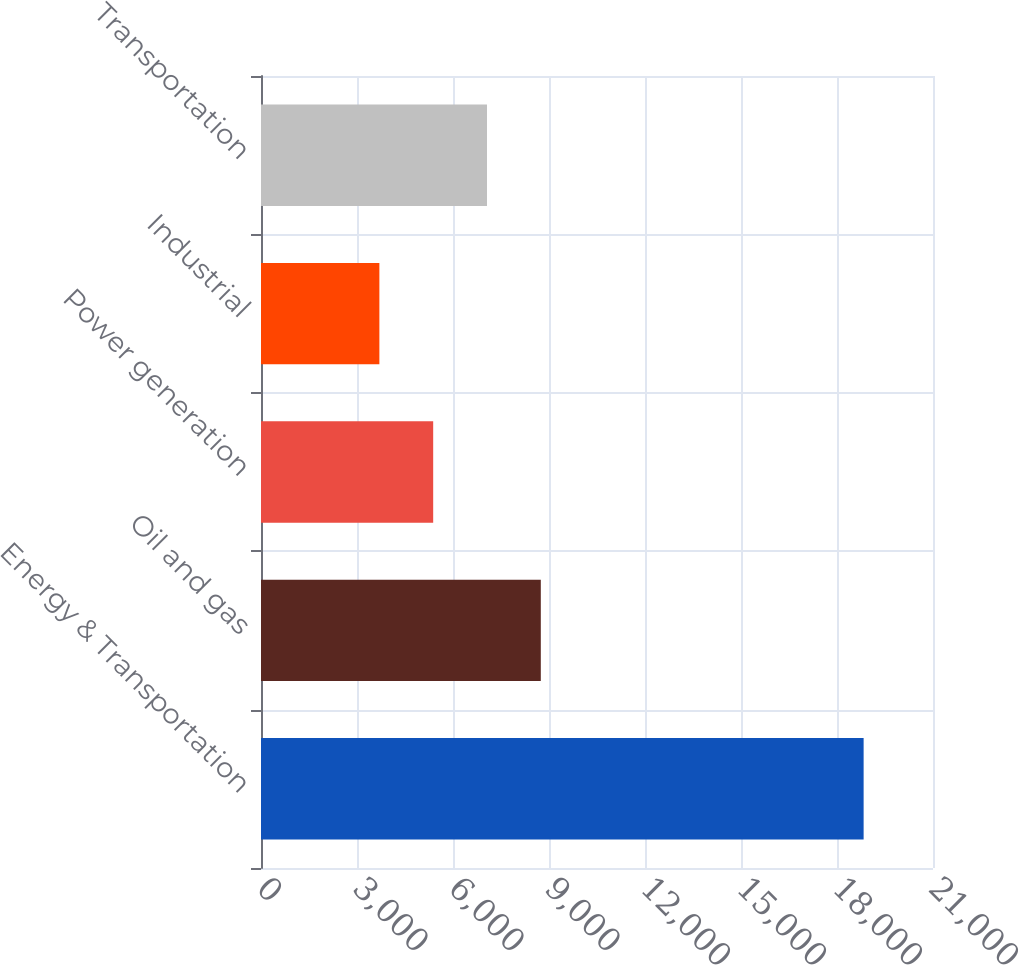Convert chart. <chart><loc_0><loc_0><loc_500><loc_500><bar_chart><fcel>Energy & Transportation<fcel>Oil and gas<fcel>Power generation<fcel>Industrial<fcel>Transportation<nl><fcel>18832<fcel>8743.6<fcel>5380.8<fcel>3699.4<fcel>7062.2<nl></chart> 